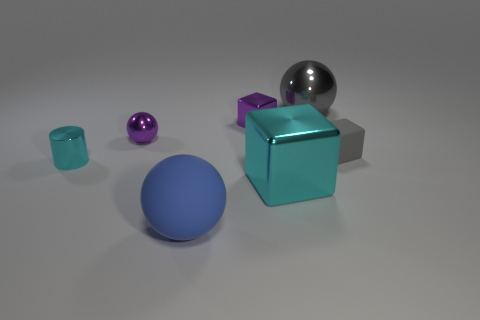Subtract all metal spheres. How many spheres are left? 1 Add 1 gray shiny objects. How many objects exist? 8 Subtract 1 cubes. How many cubes are left? 2 Subtract all cylinders. How many objects are left? 6 Add 1 small cyan metallic cylinders. How many small cyan metallic cylinders are left? 2 Add 4 big matte things. How many big matte things exist? 5 Subtract 0 red blocks. How many objects are left? 7 Subtract all green cylinders. Subtract all green cubes. How many cylinders are left? 1 Subtract all tiny purple metal things. Subtract all rubber things. How many objects are left? 3 